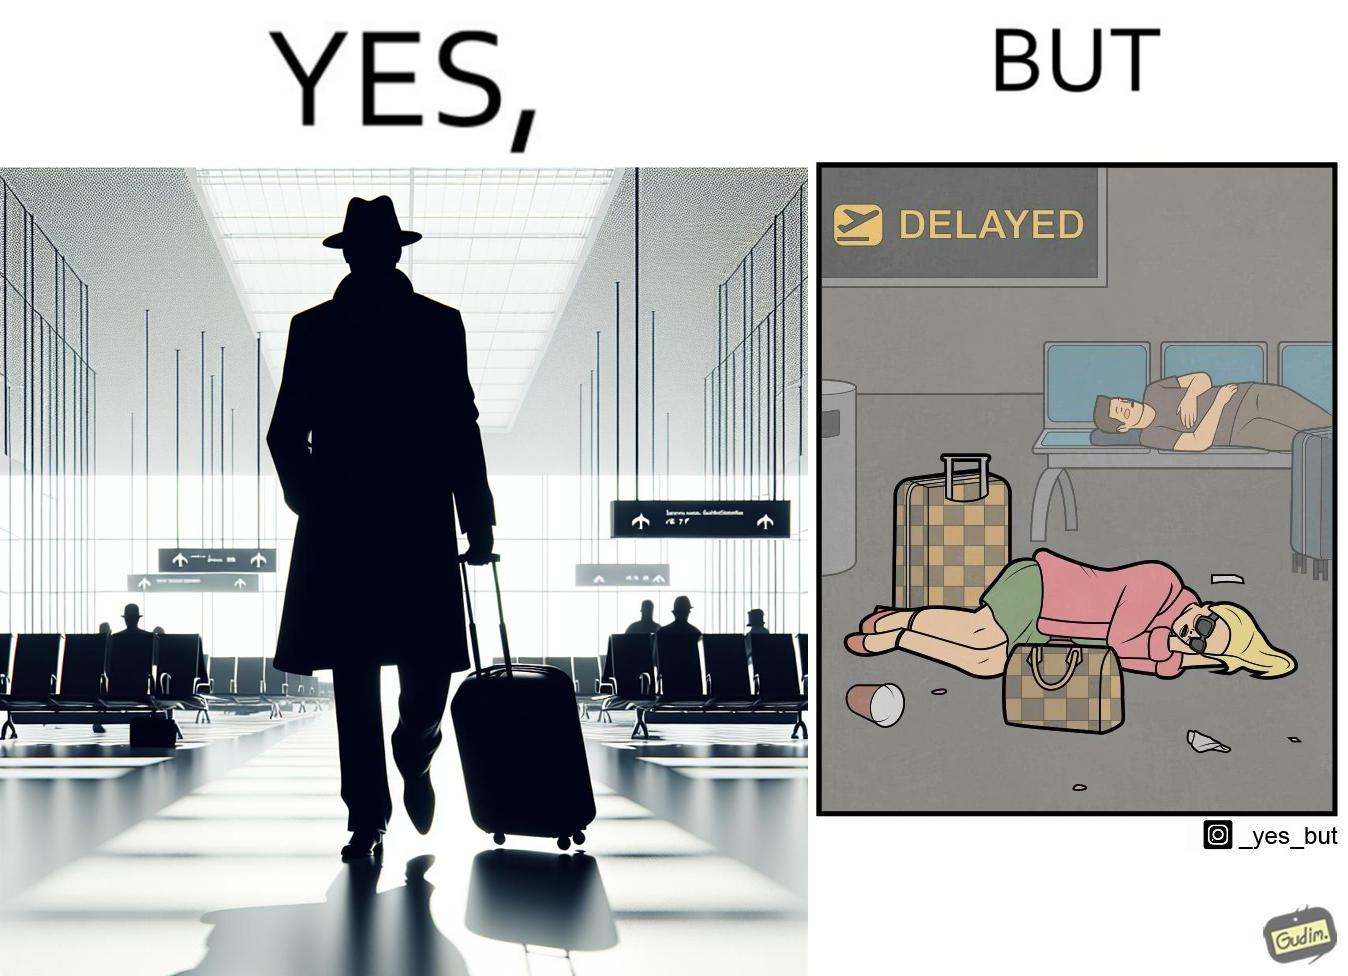What does this image depict? The image is ironical, as an apparently rich person walks inside the airport with luggage, but has to sleep on the floor  due to the flight being delayed and an absence of vacant seats in the airport. 